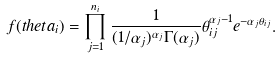<formula> <loc_0><loc_0><loc_500><loc_500>f ( t h e t a _ { i } ) = \prod _ { j = 1 } ^ { n _ { i } } \frac { 1 } { ( { 1 } / { \alpha _ { j } } ) ^ { \alpha _ { j } } \Gamma ( \alpha _ { j } ) } \theta _ { i j } ^ { \alpha _ { j } - 1 } e ^ { - \alpha _ { j } \theta _ { i j } } .</formula> 